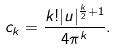Convert formula to latex. <formula><loc_0><loc_0><loc_500><loc_500>c _ { k } = \frac { k ! | u | ^ { \frac { k } { 2 } + 1 } } { 4 \pi ^ { k } } .</formula> 